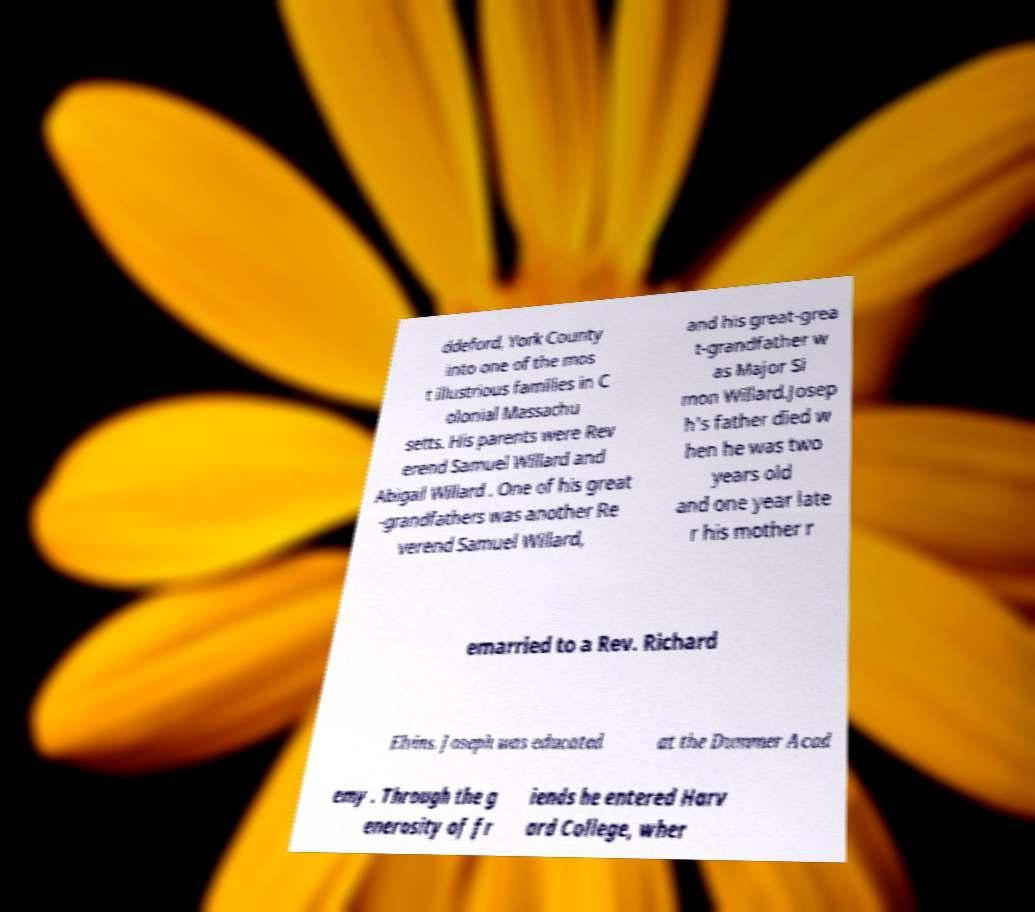What messages or text are displayed in this image? I need them in a readable, typed format. ddeford, York County into one of the mos t illustrious families in C olonial Massachu setts. His parents were Rev erend Samuel Willard and Abigail Willard . One of his great -grandfathers was another Re verend Samuel Willard, and his great-grea t-grandfather w as Major Si mon Willard.Josep h's father died w hen he was two years old and one year late r his mother r emarried to a Rev. Richard Elvins. Joseph was educated at the Dummer Acad emy . Through the g enerosity of fr iends he entered Harv ard College, wher 